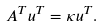<formula> <loc_0><loc_0><loc_500><loc_500>A ^ { T } u ^ { T } = \kappa u ^ { T } .</formula> 